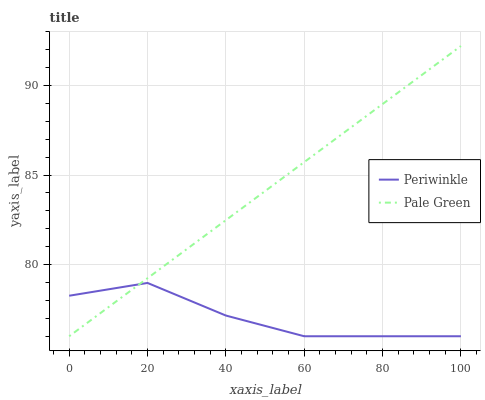Does Periwinkle have the minimum area under the curve?
Answer yes or no. Yes. Does Pale Green have the maximum area under the curve?
Answer yes or no. Yes. Does Periwinkle have the maximum area under the curve?
Answer yes or no. No. Is Pale Green the smoothest?
Answer yes or no. Yes. Is Periwinkle the roughest?
Answer yes or no. Yes. Is Periwinkle the smoothest?
Answer yes or no. No. Does Pale Green have the lowest value?
Answer yes or no. Yes. Does Pale Green have the highest value?
Answer yes or no. Yes. Does Periwinkle have the highest value?
Answer yes or no. No. Does Periwinkle intersect Pale Green?
Answer yes or no. Yes. Is Periwinkle less than Pale Green?
Answer yes or no. No. Is Periwinkle greater than Pale Green?
Answer yes or no. No. 